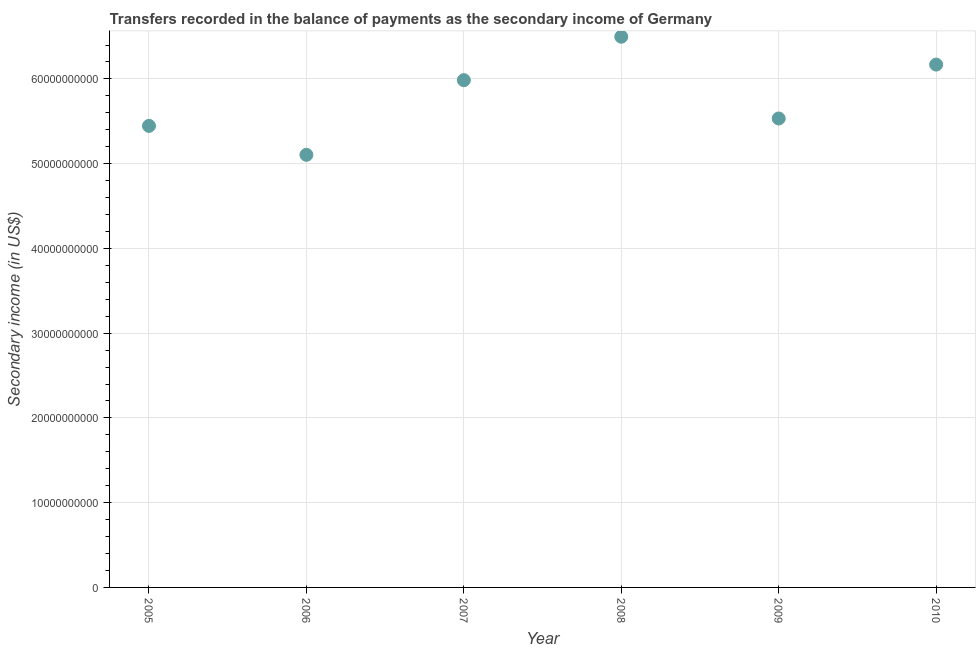What is the amount of secondary income in 2007?
Offer a terse response. 5.99e+1. Across all years, what is the maximum amount of secondary income?
Your answer should be compact. 6.50e+1. Across all years, what is the minimum amount of secondary income?
Make the answer very short. 5.10e+1. In which year was the amount of secondary income maximum?
Your answer should be compact. 2008. In which year was the amount of secondary income minimum?
Your response must be concise. 2006. What is the sum of the amount of secondary income?
Offer a terse response. 3.47e+11. What is the difference between the amount of secondary income in 2005 and 2010?
Your answer should be compact. -7.23e+09. What is the average amount of secondary income per year?
Ensure brevity in your answer.  5.79e+1. What is the median amount of secondary income?
Ensure brevity in your answer.  5.76e+1. In how many years, is the amount of secondary income greater than 10000000000 US$?
Your answer should be very brief. 6. Do a majority of the years between 2007 and 2010 (inclusive) have amount of secondary income greater than 60000000000 US$?
Your answer should be compact. No. What is the ratio of the amount of secondary income in 2007 to that in 2010?
Make the answer very short. 0.97. What is the difference between the highest and the second highest amount of secondary income?
Your answer should be compact. 3.29e+09. Is the sum of the amount of secondary income in 2007 and 2010 greater than the maximum amount of secondary income across all years?
Ensure brevity in your answer.  Yes. What is the difference between the highest and the lowest amount of secondary income?
Keep it short and to the point. 1.39e+1. In how many years, is the amount of secondary income greater than the average amount of secondary income taken over all years?
Your answer should be very brief. 3. How many years are there in the graph?
Ensure brevity in your answer.  6. Does the graph contain any zero values?
Provide a succinct answer. No. What is the title of the graph?
Offer a very short reply. Transfers recorded in the balance of payments as the secondary income of Germany. What is the label or title of the X-axis?
Provide a short and direct response. Year. What is the label or title of the Y-axis?
Offer a terse response. Secondary income (in US$). What is the Secondary income (in US$) in 2005?
Give a very brief answer. 5.45e+1. What is the Secondary income (in US$) in 2006?
Ensure brevity in your answer.  5.10e+1. What is the Secondary income (in US$) in 2007?
Provide a short and direct response. 5.99e+1. What is the Secondary income (in US$) in 2008?
Give a very brief answer. 6.50e+1. What is the Secondary income (in US$) in 2009?
Ensure brevity in your answer.  5.53e+1. What is the Secondary income (in US$) in 2010?
Your answer should be very brief. 6.17e+1. What is the difference between the Secondary income (in US$) in 2005 and 2006?
Ensure brevity in your answer.  3.42e+09. What is the difference between the Secondary income (in US$) in 2005 and 2007?
Provide a short and direct response. -5.39e+09. What is the difference between the Secondary income (in US$) in 2005 and 2008?
Give a very brief answer. -1.05e+1. What is the difference between the Secondary income (in US$) in 2005 and 2009?
Offer a terse response. -8.72e+08. What is the difference between the Secondary income (in US$) in 2005 and 2010?
Provide a succinct answer. -7.23e+09. What is the difference between the Secondary income (in US$) in 2006 and 2007?
Offer a very short reply. -8.81e+09. What is the difference between the Secondary income (in US$) in 2006 and 2008?
Keep it short and to the point. -1.39e+1. What is the difference between the Secondary income (in US$) in 2006 and 2009?
Give a very brief answer. -4.29e+09. What is the difference between the Secondary income (in US$) in 2006 and 2010?
Ensure brevity in your answer.  -1.06e+1. What is the difference between the Secondary income (in US$) in 2007 and 2008?
Provide a succinct answer. -5.13e+09. What is the difference between the Secondary income (in US$) in 2007 and 2009?
Offer a terse response. 4.52e+09. What is the difference between the Secondary income (in US$) in 2007 and 2010?
Offer a very short reply. -1.84e+09. What is the difference between the Secondary income (in US$) in 2008 and 2009?
Keep it short and to the point. 9.65e+09. What is the difference between the Secondary income (in US$) in 2008 and 2010?
Ensure brevity in your answer.  3.29e+09. What is the difference between the Secondary income (in US$) in 2009 and 2010?
Offer a very short reply. -6.36e+09. What is the ratio of the Secondary income (in US$) in 2005 to that in 2006?
Provide a short and direct response. 1.07. What is the ratio of the Secondary income (in US$) in 2005 to that in 2007?
Offer a very short reply. 0.91. What is the ratio of the Secondary income (in US$) in 2005 to that in 2008?
Offer a very short reply. 0.84. What is the ratio of the Secondary income (in US$) in 2005 to that in 2010?
Offer a terse response. 0.88. What is the ratio of the Secondary income (in US$) in 2006 to that in 2007?
Make the answer very short. 0.85. What is the ratio of the Secondary income (in US$) in 2006 to that in 2008?
Offer a terse response. 0.79. What is the ratio of the Secondary income (in US$) in 2006 to that in 2009?
Provide a succinct answer. 0.92. What is the ratio of the Secondary income (in US$) in 2006 to that in 2010?
Your answer should be compact. 0.83. What is the ratio of the Secondary income (in US$) in 2007 to that in 2008?
Offer a very short reply. 0.92. What is the ratio of the Secondary income (in US$) in 2007 to that in 2009?
Make the answer very short. 1.08. What is the ratio of the Secondary income (in US$) in 2007 to that in 2010?
Offer a very short reply. 0.97. What is the ratio of the Secondary income (in US$) in 2008 to that in 2009?
Provide a short and direct response. 1.17. What is the ratio of the Secondary income (in US$) in 2008 to that in 2010?
Offer a very short reply. 1.05. What is the ratio of the Secondary income (in US$) in 2009 to that in 2010?
Your answer should be very brief. 0.9. 